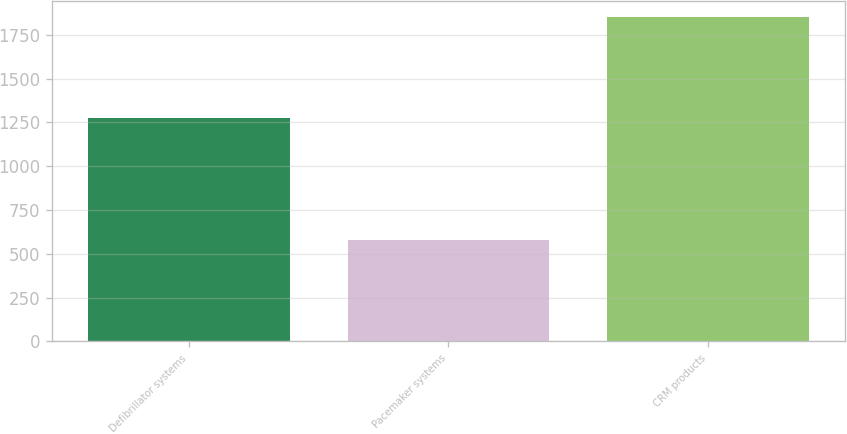<chart> <loc_0><loc_0><loc_500><loc_500><bar_chart><fcel>Defibrillator systems<fcel>Pacemaker systems<fcel>CRM products<nl><fcel>1274<fcel>576<fcel>1850<nl></chart> 